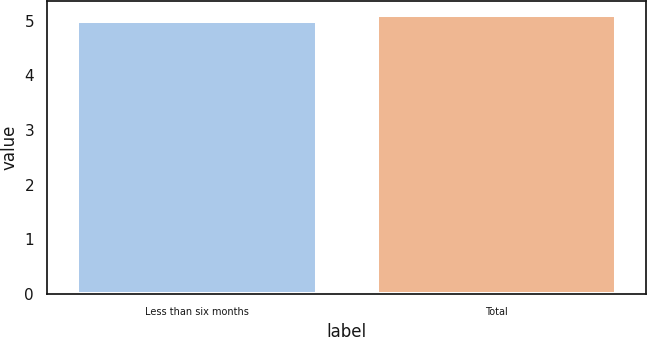Convert chart. <chart><loc_0><loc_0><loc_500><loc_500><bar_chart><fcel>Less than six months<fcel>Total<nl><fcel>5<fcel>5.1<nl></chart> 